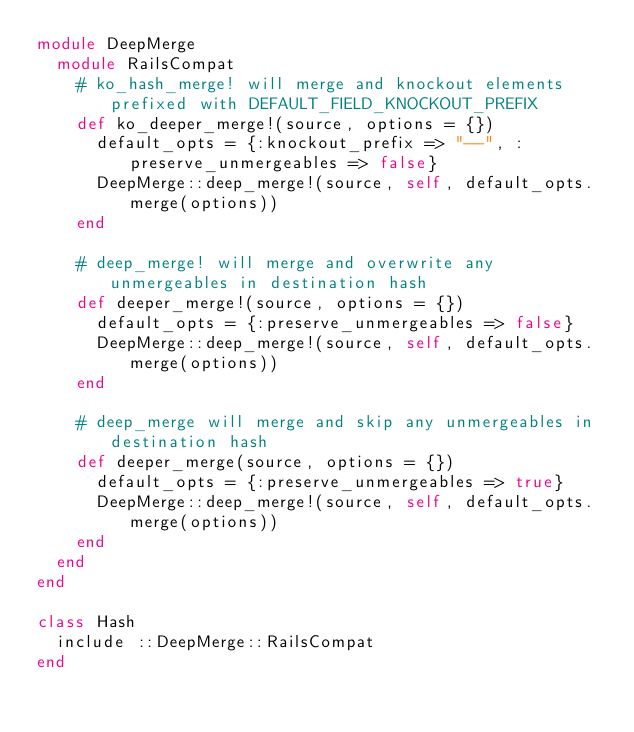Convert code to text. <code><loc_0><loc_0><loc_500><loc_500><_Ruby_>module DeepMerge
  module RailsCompat
    # ko_hash_merge! will merge and knockout elements prefixed with DEFAULT_FIELD_KNOCKOUT_PREFIX
    def ko_deeper_merge!(source, options = {})
      default_opts = {:knockout_prefix => "--", :preserve_unmergeables => false}
      DeepMerge::deep_merge!(source, self, default_opts.merge(options))
    end

    # deep_merge! will merge and overwrite any unmergeables in destination hash
    def deeper_merge!(source, options = {})
      default_opts = {:preserve_unmergeables => false}
      DeepMerge::deep_merge!(source, self, default_opts.merge(options))
    end

    # deep_merge will merge and skip any unmergeables in destination hash
    def deeper_merge(source, options = {})
      default_opts = {:preserve_unmergeables => true}
      DeepMerge::deep_merge!(source, self, default_opts.merge(options))
    end
  end
end

class Hash
  include ::DeepMerge::RailsCompat
end</code> 